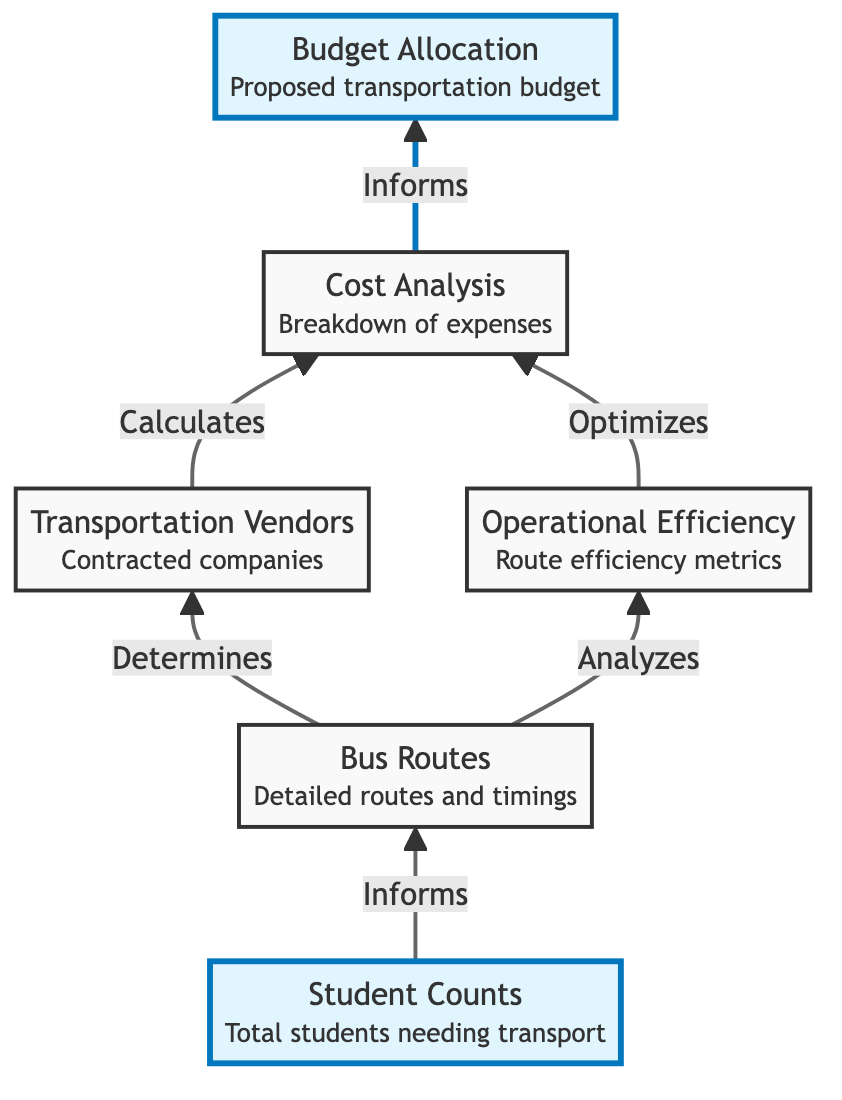What is the first node in the flow chart? The first node in the flow chart is "Student Counts" which signifies the starting point of the analysis for transportation costs.
Answer: Student Counts How many nodes are in the diagram? Counting all the unique identifiers in the diagram, there are six nodes that represent different aspects of transportation cost analysis.
Answer: Six What does the "Bus Routes" node determine? The "Bus Routes" node determines which transportation vendors are contracted based on the established routes from the analysis of student counts.
Answer: Transportation Vendors Which node provides data to optimize costs? The "Operational Efficiency" node provides data that can be utilized to optimize costs in the "Cost Analysis" node through efficient routing methodologies.
Answer: Cost Analysis What informs the "Budget Allocation"? The "Cost Analysis" directly informs the "Budget Allocation" by providing a breakdown of transportation costs that are essential for effective budget decisions.
Answer: Cost Analysis What connects the "Student Counts" to "Bus Routes"? The relationship between "Student Counts" and "Bus Routes" is that the number of students needing transport directly informs the planning of bus routes for effective transportation.
Answer: Bus Routes Which node analyzes routes for improvements? The "Bus Routes" node analyzes routes to identify areas where improvements may be required to enhance transportation efficiency.
Answer: Operational Efficiency How does "Operational Efficiency" affect "Cost Analysis"? The "Operational Efficiency" node affects the "Cost Analysis" by providing data that can lead to cost optimization through the analysis of routing efficiency.
Answer: Cost Analysis How many connections are represented in the diagram? There are six connections that illustrate the relationships among the nodes in the diagram regarding transportation costs and routing analysis.
Answer: Six 